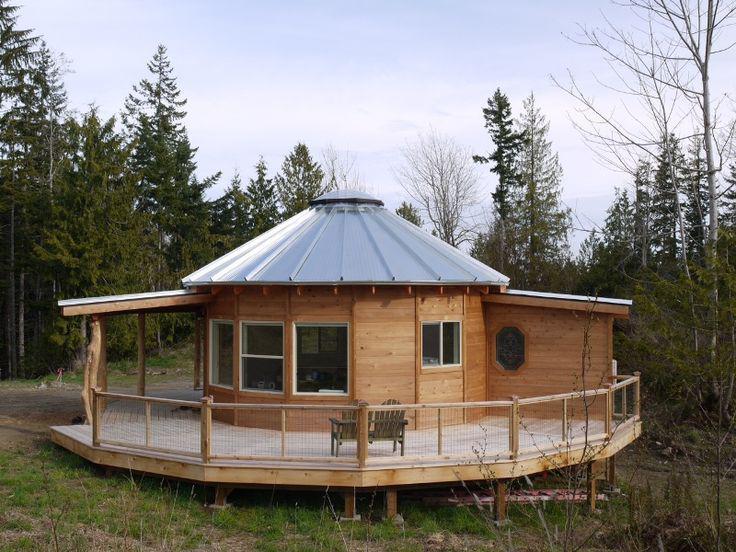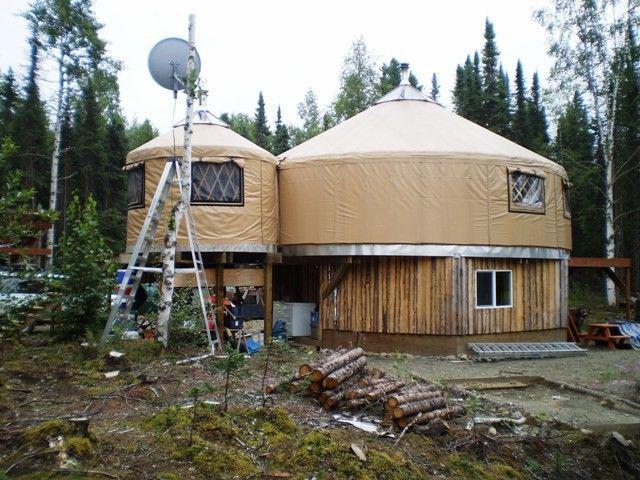The first image is the image on the left, the second image is the image on the right. Evaluate the accuracy of this statement regarding the images: "Two round houses are sitting in snowy areas.". Is it true? Answer yes or no. No. The first image is the image on the left, the second image is the image on the right. Evaluate the accuracy of this statement regarding the images: "An image shows side-by-side joined structures, both with cone/dome tops.". Is it true? Answer yes or no. Yes. 